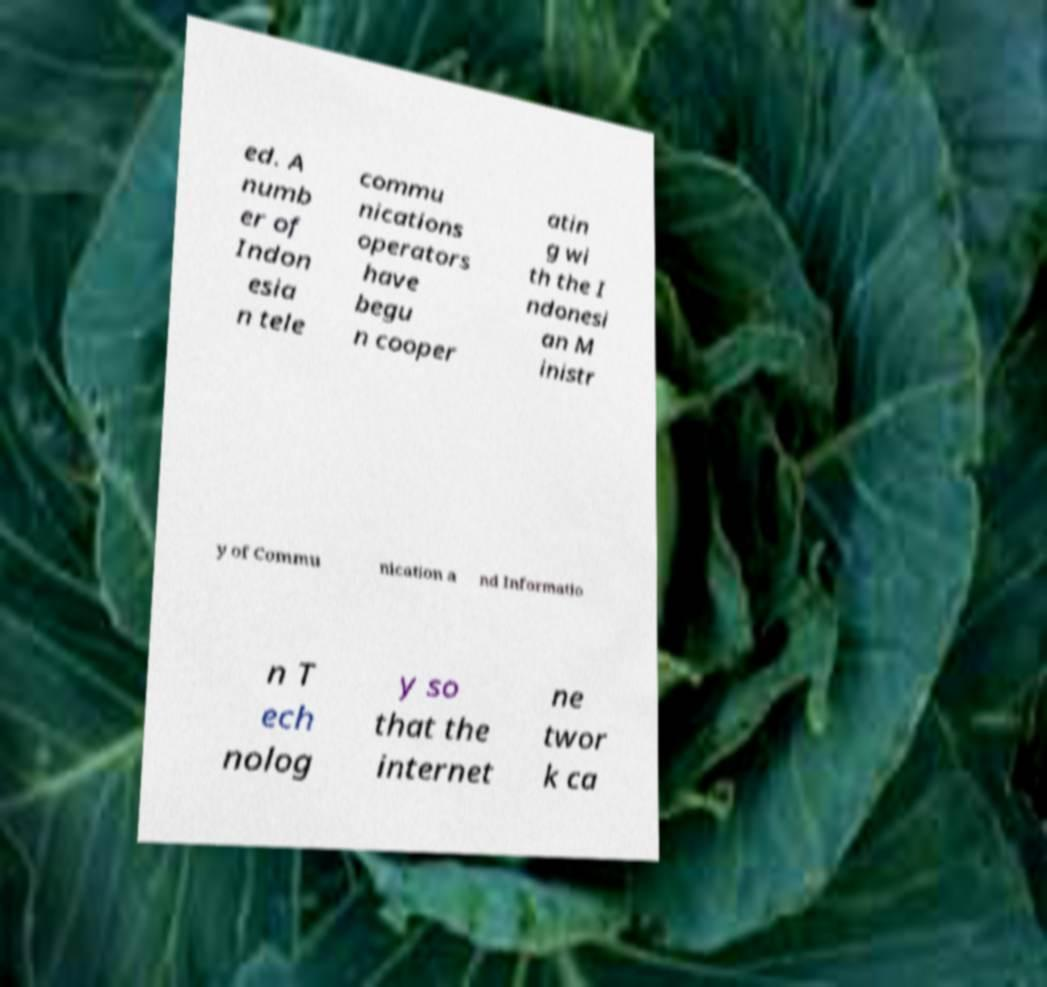What messages or text are displayed in this image? I need them in a readable, typed format. ed. A numb er of Indon esia n tele commu nications operators have begu n cooper atin g wi th the I ndonesi an M inistr y of Commu nication a nd Informatio n T ech nolog y so that the internet ne twor k ca 